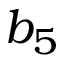<formula> <loc_0><loc_0><loc_500><loc_500>b _ { 5 }</formula> 